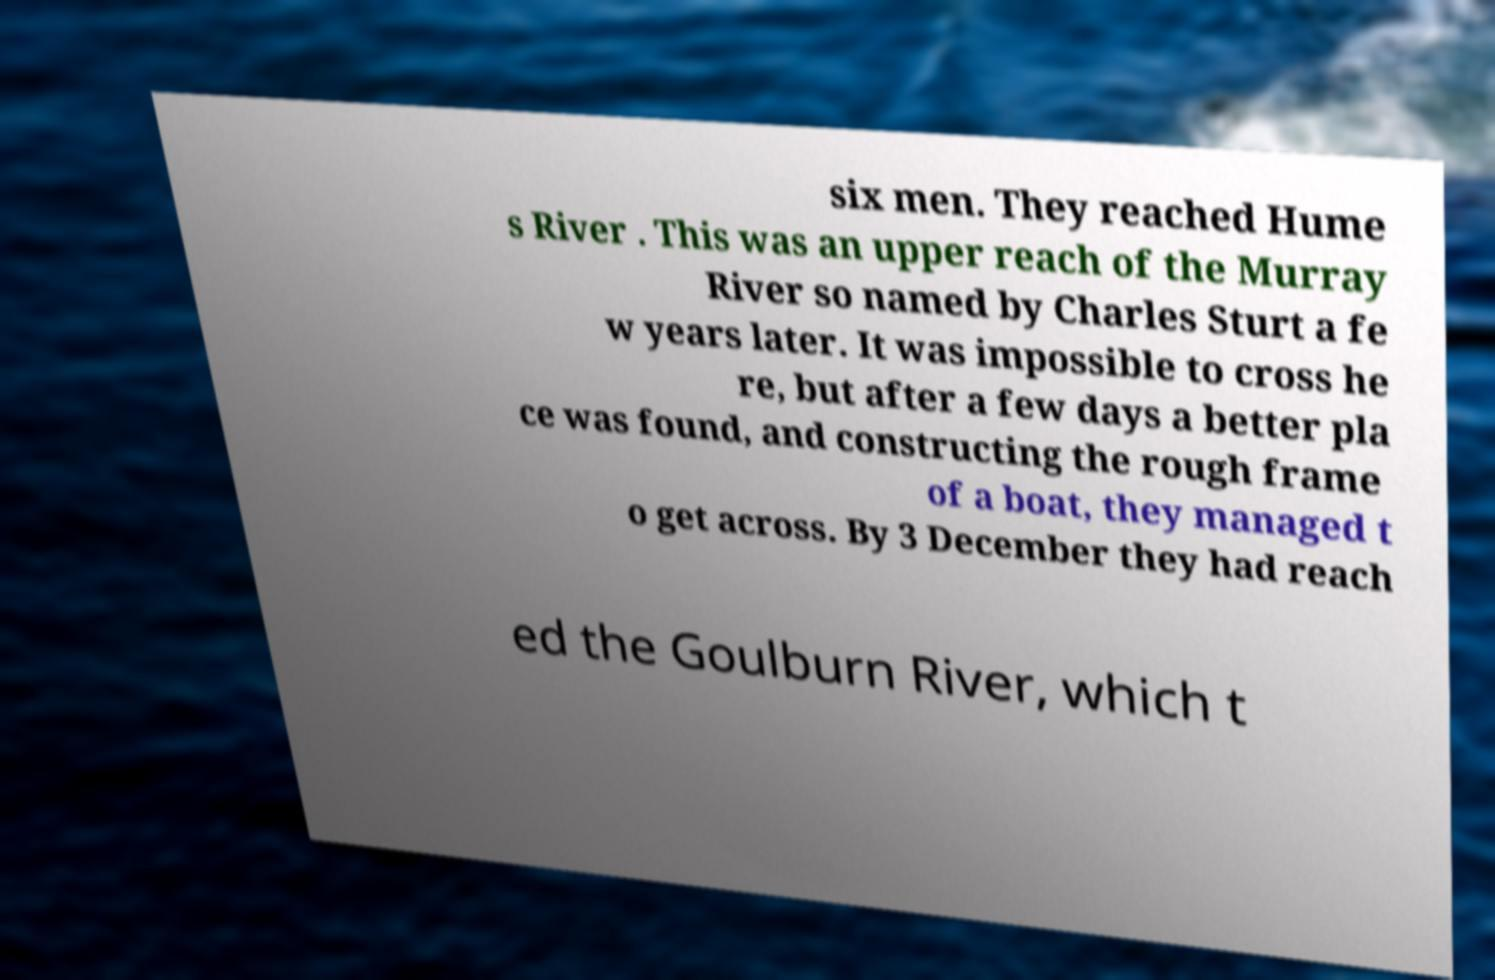I need the written content from this picture converted into text. Can you do that? six men. They reached Hume s River . This was an upper reach of the Murray River so named by Charles Sturt a fe w years later. It was impossible to cross he re, but after a few days a better pla ce was found, and constructing the rough frame of a boat, they managed t o get across. By 3 December they had reach ed the Goulburn River, which t 